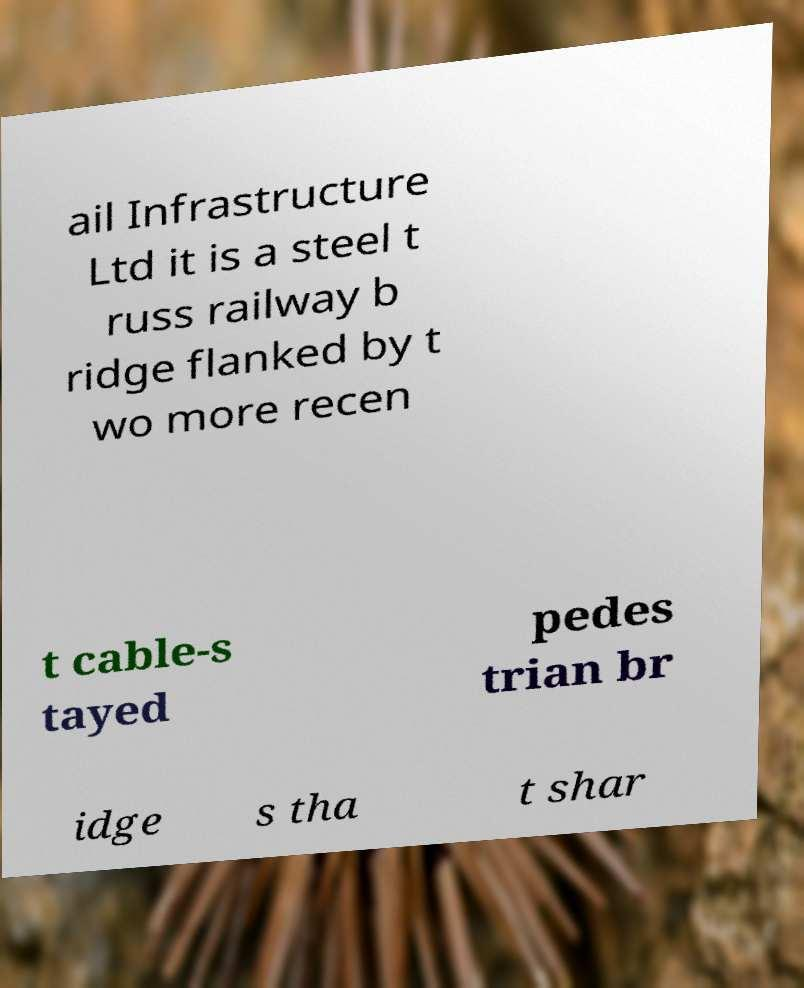I need the written content from this picture converted into text. Can you do that? ail Infrastructure Ltd it is a steel t russ railway b ridge flanked by t wo more recen t cable-s tayed pedes trian br idge s tha t shar 